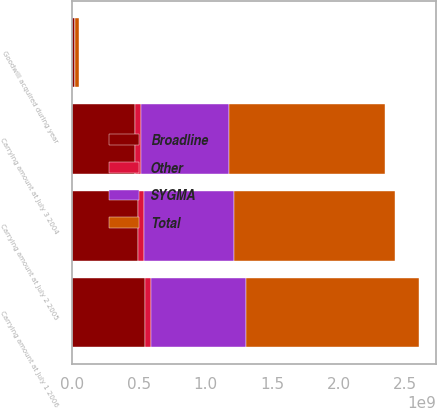<chart> <loc_0><loc_0><loc_500><loc_500><stacked_bar_chart><ecel><fcel>Carrying amount at July 3 2004<fcel>Goodwill acquired during year<fcel>Carrying amount at July 2 2005<fcel>Carrying amount at July 1 2006<nl><fcel>SYGMA<fcel>6.60098e+08<fcel>3.589e+06<fcel>6.76346e+08<fcel>7.09414e+08<nl><fcel>Other<fcel>4.3875e+07<fcel>606000<fcel>4.4481e+07<fcel>4.693e+07<nl><fcel>Broadline<fcel>4.70818e+08<fcel>2.1198e+07<fcel>4.91776e+08<fcel>5.46247e+08<nl><fcel>Total<fcel>1.17479e+09<fcel>2.5393e+07<fcel>1.2126e+09<fcel>1.30259e+09<nl></chart> 